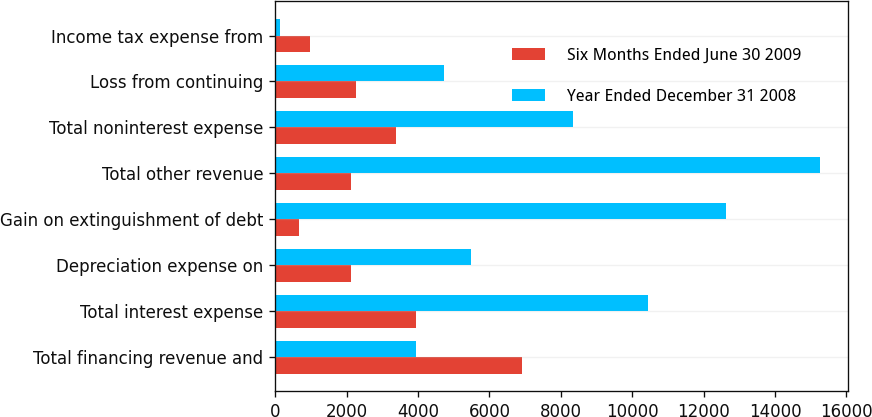Convert chart. <chart><loc_0><loc_0><loc_500><loc_500><stacked_bar_chart><ecel><fcel>Total financing revenue and<fcel>Total interest expense<fcel>Depreciation expense on<fcel>Gain on extinguishment of debt<fcel>Total other revenue<fcel>Total noninterest expense<fcel>Loss from continuing<fcel>Income tax expense from<nl><fcel>Six Months Ended June 30 2009<fcel>6916<fcel>3936<fcel>2113<fcel>657<fcel>2117<fcel>3381<fcel>2260<fcel>972<nl><fcel>Year Ended December 31 2008<fcel>3936<fcel>10441<fcel>5478<fcel>12628<fcel>15271<fcel>8349<fcel>4737<fcel>136<nl></chart> 